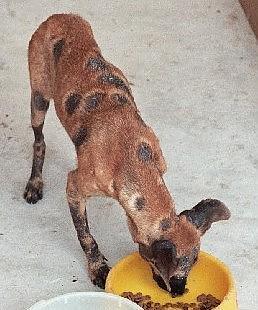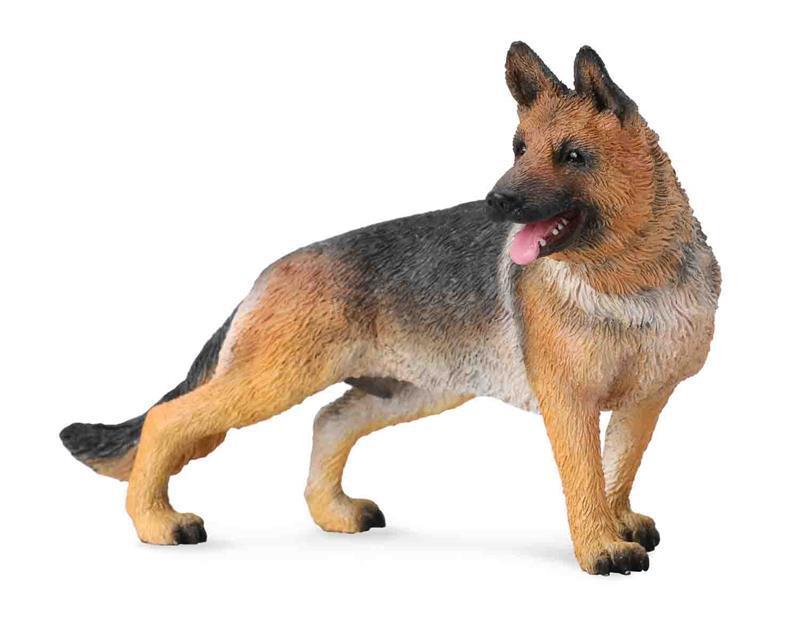The first image is the image on the left, the second image is the image on the right. Analyze the images presented: Is the assertion "An image contains a dog eating dog food from a bowl." valid? Answer yes or no. Yes. The first image is the image on the left, the second image is the image on the right. Considering the images on both sides, is "One dog is eating and has its head near a round bowl of food, and the other dog figure is standing on all fours." valid? Answer yes or no. Yes. 